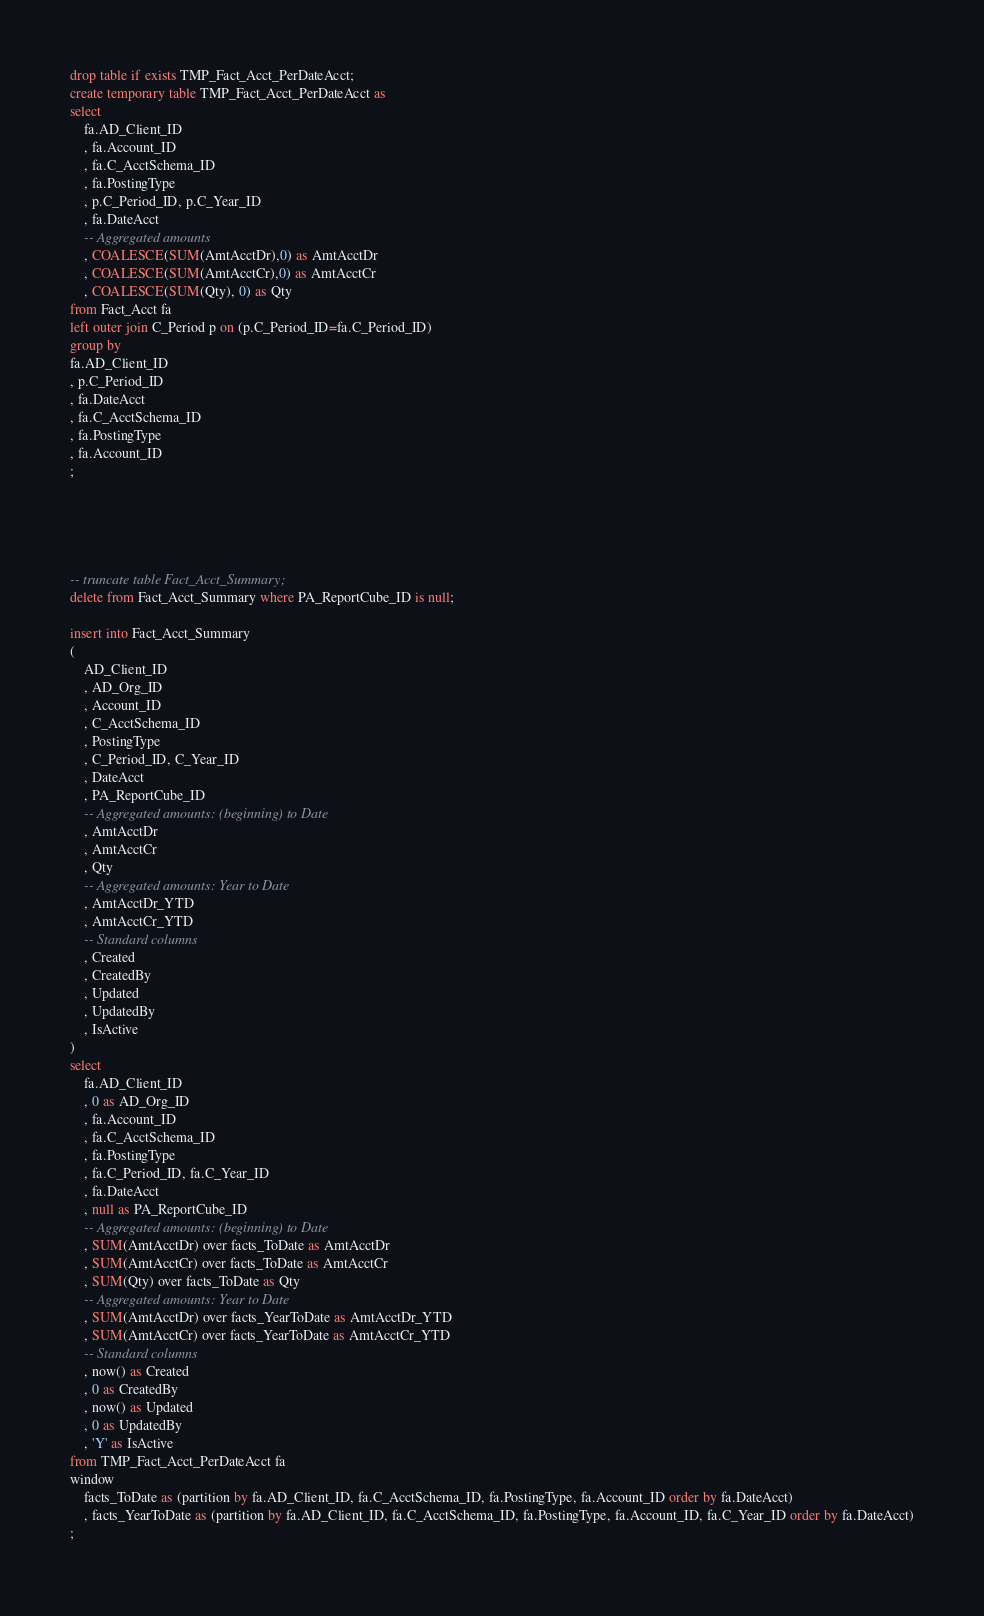<code> <loc_0><loc_0><loc_500><loc_500><_SQL_>drop table if exists TMP_Fact_Acct_PerDateAcct;
create temporary table TMP_Fact_Acct_PerDateAcct as
select
	fa.AD_Client_ID
	, fa.Account_ID
	, fa.C_AcctSchema_ID
	, fa.PostingType
	, p.C_Period_ID, p.C_Year_ID
	, fa.DateAcct
	-- Aggregated amounts
	, COALESCE(SUM(AmtAcctDr),0) as AmtAcctDr
	, COALESCE(SUM(AmtAcctCr),0) as AmtAcctCr
	, COALESCE(SUM(Qty), 0) as Qty
from Fact_Acct fa
left outer join C_Period p on (p.C_Period_ID=fa.C_Period_ID)
group by
fa.AD_Client_ID
, p.C_Period_ID
, fa.DateAcct
, fa.C_AcctSchema_ID
, fa.PostingType
, fa.Account_ID
;





-- truncate table Fact_Acct_Summary;
delete from Fact_Acct_Summary where PA_ReportCube_ID is null;

insert into Fact_Acct_Summary
(
	AD_Client_ID
	, AD_Org_ID
	, Account_ID
	, C_AcctSchema_ID
	, PostingType
	, C_Period_ID, C_Year_ID
	, DateAcct
	, PA_ReportCube_ID
	-- Aggregated amounts: (beginning) to Date
	, AmtAcctDr
	, AmtAcctCr
	, Qty
	-- Aggregated amounts: Year to Date
	, AmtAcctDr_YTD
	, AmtAcctCr_YTD
	-- Standard columns
	, Created
	, CreatedBy
	, Updated
	, UpdatedBy
	, IsActive
)
select
	fa.AD_Client_ID
	, 0 as AD_Org_ID
	, fa.Account_ID
	, fa.C_AcctSchema_ID
	, fa.PostingType
	, fa.C_Period_ID, fa.C_Year_ID
	, fa.DateAcct
	, null as PA_ReportCube_ID
	-- Aggregated amounts: (beginning) to Date
	, SUM(AmtAcctDr) over facts_ToDate as AmtAcctDr
	, SUM(AmtAcctCr) over facts_ToDate as AmtAcctCr
	, SUM(Qty) over facts_ToDate as Qty
	-- Aggregated amounts: Year to Date
	, SUM(AmtAcctDr) over facts_YearToDate as AmtAcctDr_YTD
	, SUM(AmtAcctCr) over facts_YearToDate as AmtAcctCr_YTD
	-- Standard columns
	, now() as Created
	, 0 as CreatedBy
	, now() as Updated
	, 0 as UpdatedBy
	, 'Y' as IsActive
from TMP_Fact_Acct_PerDateAcct fa
window
	facts_ToDate as (partition by fa.AD_Client_ID, fa.C_AcctSchema_ID, fa.PostingType, fa.Account_ID order by fa.DateAcct)
	, facts_YearToDate as (partition by fa.AD_Client_ID, fa.C_AcctSchema_ID, fa.PostingType, fa.Account_ID, fa.C_Year_ID order by fa.DateAcct)
;

</code> 